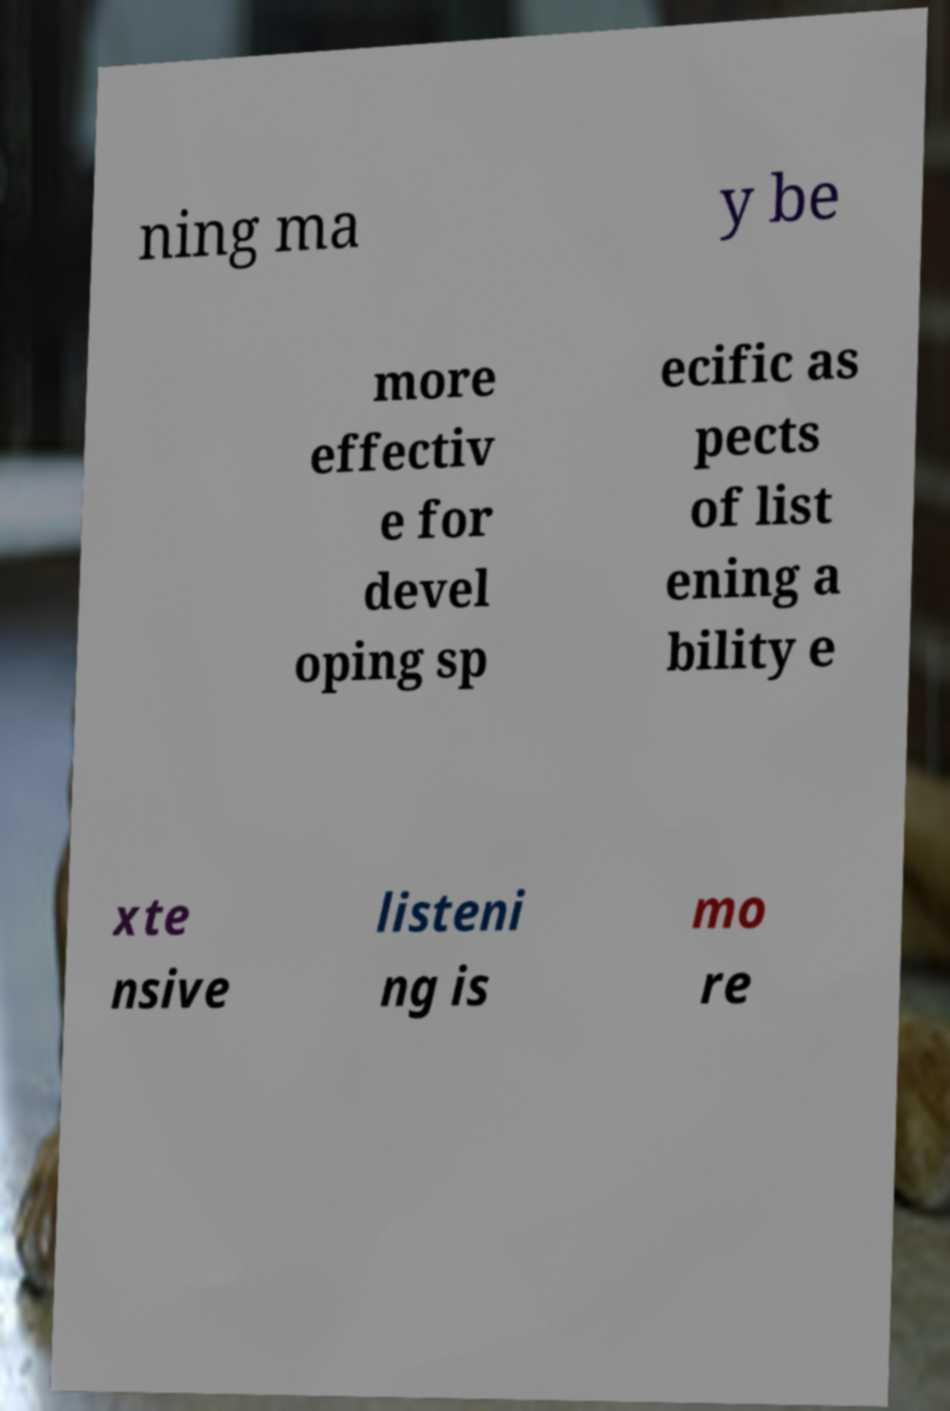Can you read and provide the text displayed in the image?This photo seems to have some interesting text. Can you extract and type it out for me? ning ma y be more effectiv e for devel oping sp ecific as pects of list ening a bility e xte nsive listeni ng is mo re 